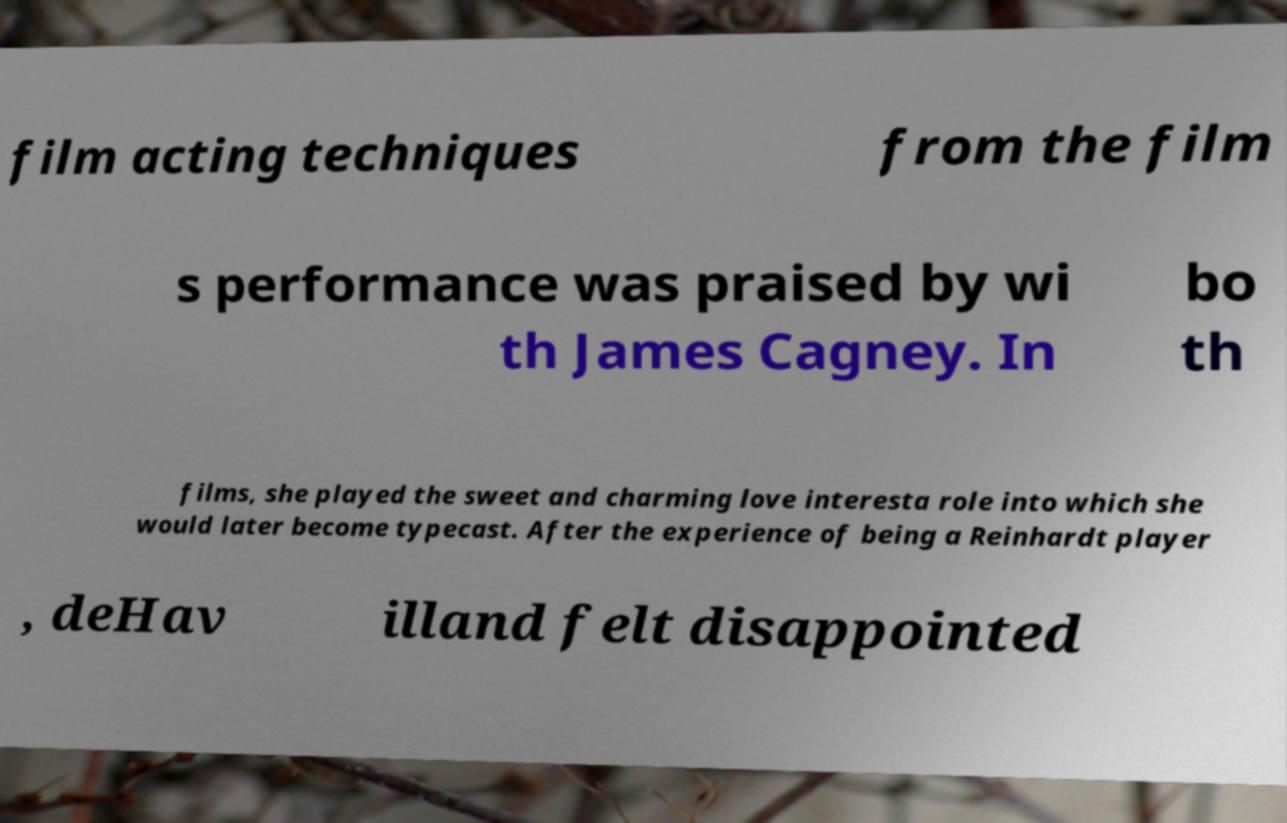Please read and relay the text visible in this image. What does it say? film acting techniques from the film s performance was praised by wi th James Cagney. In bo th films, she played the sweet and charming love interesta role into which she would later become typecast. After the experience of being a Reinhardt player , deHav illand felt disappointed 